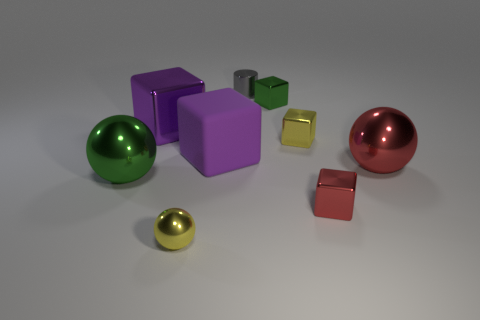There is a tiny green shiny thing; what shape is it?
Your answer should be compact. Cube. Do the green shiny object that is behind the large purple matte object and the big red thing have the same shape?
Offer a terse response. No. Is the number of small gray metal objects that are to the right of the tiny red metallic thing greater than the number of red shiny balls that are behind the tiny green thing?
Your response must be concise. No. How many other objects are there of the same size as the cylinder?
Provide a short and direct response. 4. There is a purple rubber thing; does it have the same shape as the green object that is on the left side of the gray cylinder?
Provide a short and direct response. No. How many metal objects are either big red spheres or yellow balls?
Make the answer very short. 2. Are there any big spheres of the same color as the metal cylinder?
Offer a very short reply. No. Is there a small red block?
Make the answer very short. Yes. Is the shape of the purple rubber object the same as the gray metallic thing?
Your response must be concise. No. What number of small things are blue metal blocks or red shiny cubes?
Your answer should be compact. 1. 